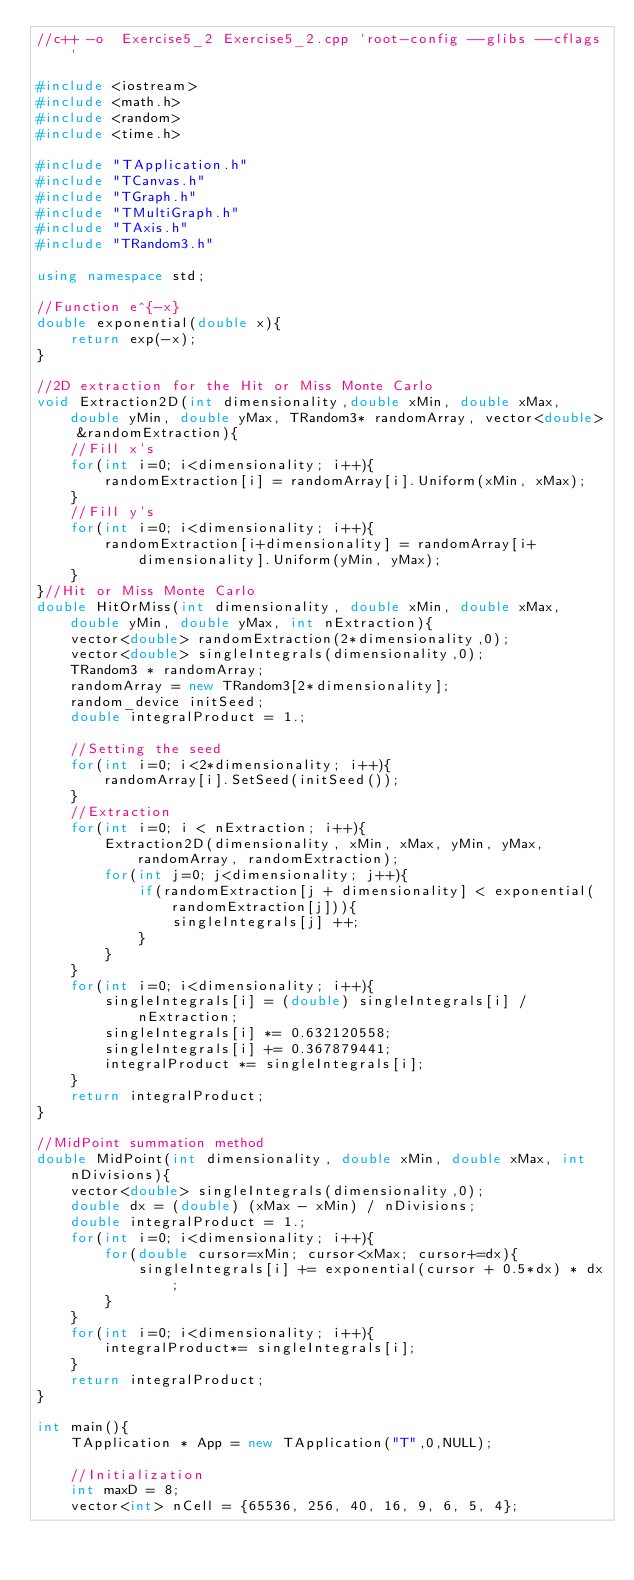<code> <loc_0><loc_0><loc_500><loc_500><_C++_>//c++ -o  Exercise5_2 Exercise5_2.cpp `root-config --glibs --cflags`

#include <iostream>
#include <math.h>
#include <random>
#include <time.h>

#include "TApplication.h"
#include "TCanvas.h"
#include "TGraph.h"
#include "TMultiGraph.h" 
#include "TAxis.h"
#include "TRandom3.h"

using namespace std;

//Function e^{-x}
double exponential(double x){
    return exp(-x);
}

//2D extraction for the Hit or Miss Monte Carlo
void Extraction2D(int dimensionality,double xMin, double xMax, double yMin, double yMax, TRandom3* randomArray, vector<double> &randomExtraction){
    //Fill x's
    for(int i=0; i<dimensionality; i++){
        randomExtraction[i] = randomArray[i].Uniform(xMin, xMax);
    }
    //Fill y's
    for(int i=0; i<dimensionality; i++){
        randomExtraction[i+dimensionality] = randomArray[i+dimensionality].Uniform(yMin, yMax);
    }
}//Hit or Miss Monte Carlo
double HitOrMiss(int dimensionality, double xMin, double xMax, double yMin, double yMax, int nExtraction){
    vector<double> randomExtraction(2*dimensionality,0);
    vector<double> singleIntegrals(dimensionality,0);
    TRandom3 * randomArray;
    randomArray = new TRandom3[2*dimensionality];
    random_device initSeed;
    double integralProduct = 1.;

    //Setting the seed
    for(int i=0; i<2*dimensionality; i++){
        randomArray[i].SetSeed(initSeed());
    }
    //Extraction
    for(int i=0; i < nExtraction; i++){
        Extraction2D(dimensionality, xMin, xMax, yMin, yMax, randomArray, randomExtraction);
        for(int j=0; j<dimensionality; j++){
            if(randomExtraction[j + dimensionality] < exponential(randomExtraction[j])){
                singleIntegrals[j] ++;
            }
        }
    }
    for(int i=0; i<dimensionality; i++){
        singleIntegrals[i] = (double) singleIntegrals[i] / nExtraction;
        singleIntegrals[i] *= 0.632120558;
        singleIntegrals[i] += 0.367879441;
        integralProduct *= singleIntegrals[i];
    }
    return integralProduct;
}

//MidPoint summation method
double MidPoint(int dimensionality, double xMin, double xMax, int nDivisions){
    vector<double> singleIntegrals(dimensionality,0);
    double dx = (double) (xMax - xMin) / nDivisions;
    double integralProduct = 1.;
    for(int i=0; i<dimensionality; i++){
        for(double cursor=xMin; cursor<xMax; cursor+=dx){
            singleIntegrals[i] += exponential(cursor + 0.5*dx) * dx;
        }
    }
    for(int i=0; i<dimensionality; i++){
        integralProduct*= singleIntegrals[i];
    }
    return integralProduct;
}

int main(){
    TApplication * App = new TApplication("T",0,NULL);

    //Initialization
    int maxD = 8;
    vector<int> nCell = {65536, 256, 40, 16, 9, 6, 5, 4};</code> 